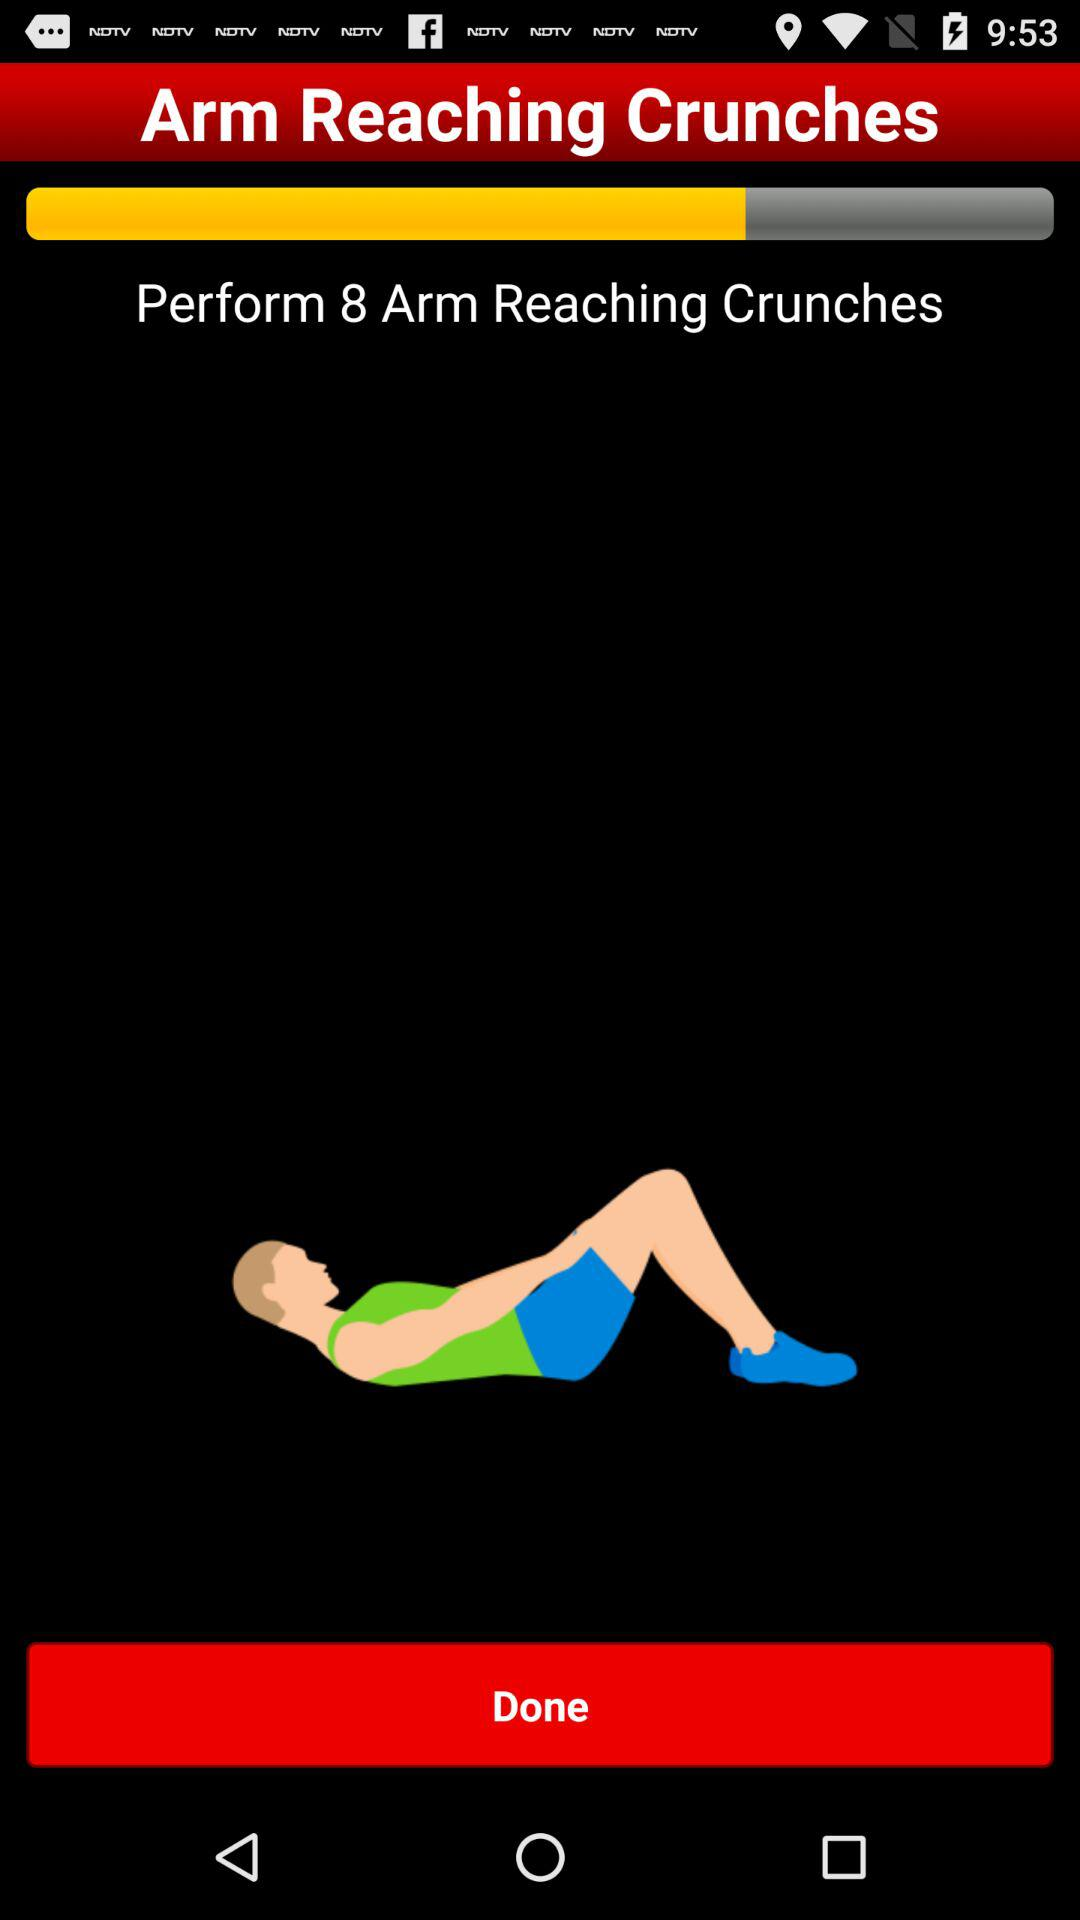How many arm reaching crunches are given to perform? There are 8 arm reaching crunches to perform. 